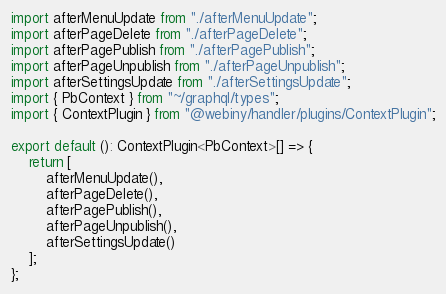Convert code to text. <code><loc_0><loc_0><loc_500><loc_500><_TypeScript_>import afterMenuUpdate from "./afterMenuUpdate";
import afterPageDelete from "./afterPageDelete";
import afterPagePublish from "./afterPagePublish";
import afterPageUnpublish from "./afterPageUnpublish";
import afterSettingsUpdate from "./afterSettingsUpdate";
import { PbContext } from "~/graphql/types";
import { ContextPlugin } from "@webiny/handler/plugins/ContextPlugin";

export default (): ContextPlugin<PbContext>[] => {
    return [
        afterMenuUpdate(),
        afterPageDelete(),
        afterPagePublish(),
        afterPageUnpublish(),
        afterSettingsUpdate()
    ];
};
</code> 